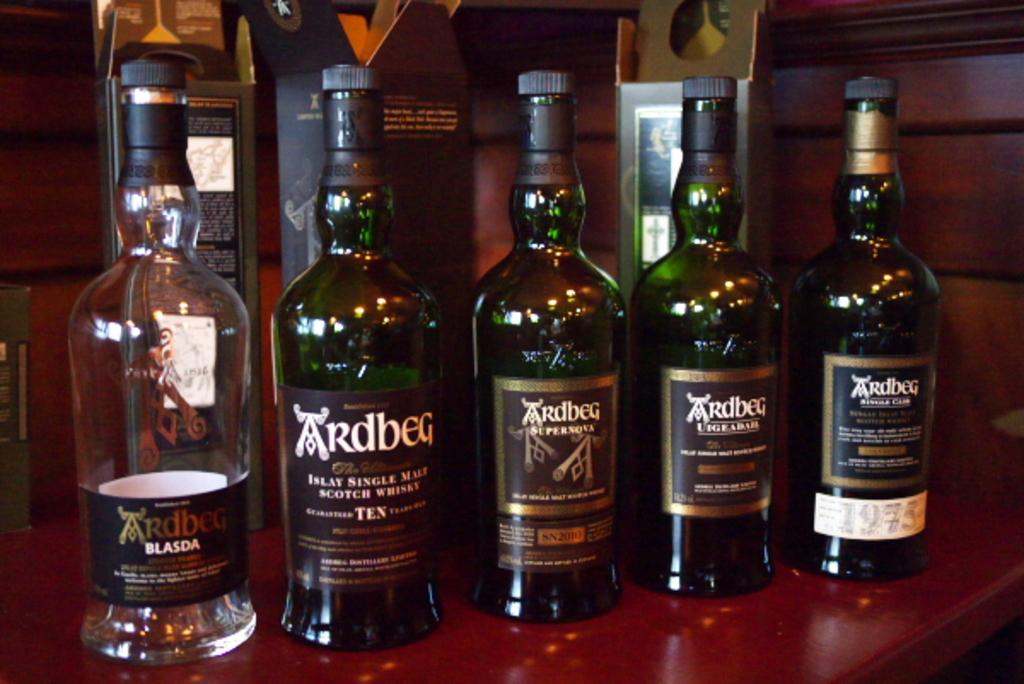How many malt is this scotch whiskey?
Your response must be concise. Single. 